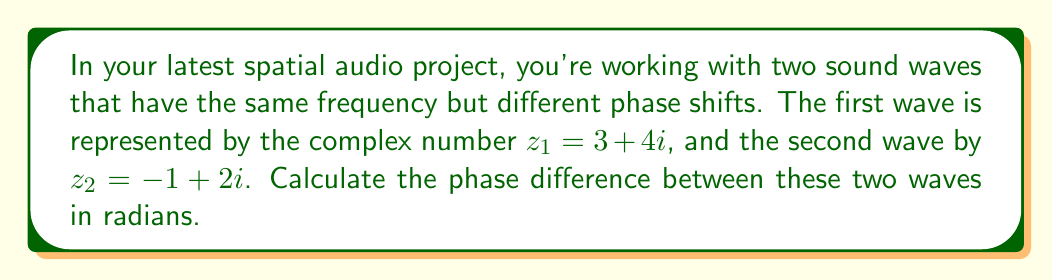Provide a solution to this math problem. To solve this problem, we need to follow these steps:

1) Recall that a complex number $z = a + bi$ can be represented in polar form as $z = r(\cos\theta + i\sin\theta)$, where $r$ is the magnitude and $\theta$ is the phase angle.

2) The phase angle $\theta$ can be calculated using the arctangent function: $\theta = \arctan(\frac{b}{a})$

3) For $z_1 = 3 + 4i$:
   $\theta_1 = \arctan(\frac{4}{3})$

4) For $z_2 = -1 + 2i$:
   $\theta_2 = \arctan(\frac{2}{-1}) + \pi$
   (We add $\pi$ because the real part is negative, placing this in the 2nd quadrant)

5) The phase difference is the absolute value of the difference between these angles:
   $\Delta\theta = |\theta_2 - \theta_1|$

6) Calculating:
   $\theta_1 = \arctan(\frac{4}{3}) \approx 0.9273$ radians
   $\theta_2 = \arctan(\frac{2}{-1}) + \pi \approx 2.0344 + \pi \approx 5.1760$ radians

7) Therefore:
   $\Delta\theta = |5.1760 - 0.9273| \approx 4.2487$ radians
Answer: The phase difference between the two waves is approximately 4.2487 radians. 